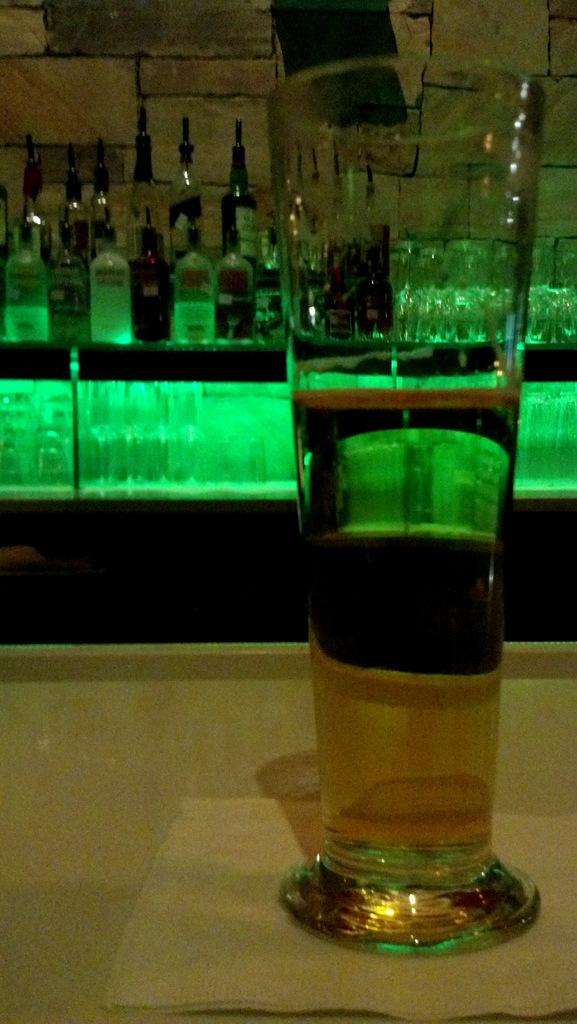What is present on the surface in the image? There is a glass in the image, and it is on a tissue. What is inside the glass? The glass contains a drink. What type of furniture is visible in the image? There is a table in the image. What else can be found on the table? There are bottles and glasses on the table. How many volleyballs are visible on the table in the image? There are no volleyballs present in the image. What type of ornament is hanging from the glass in the image? There is no ornament hanging from the glass in the image. 